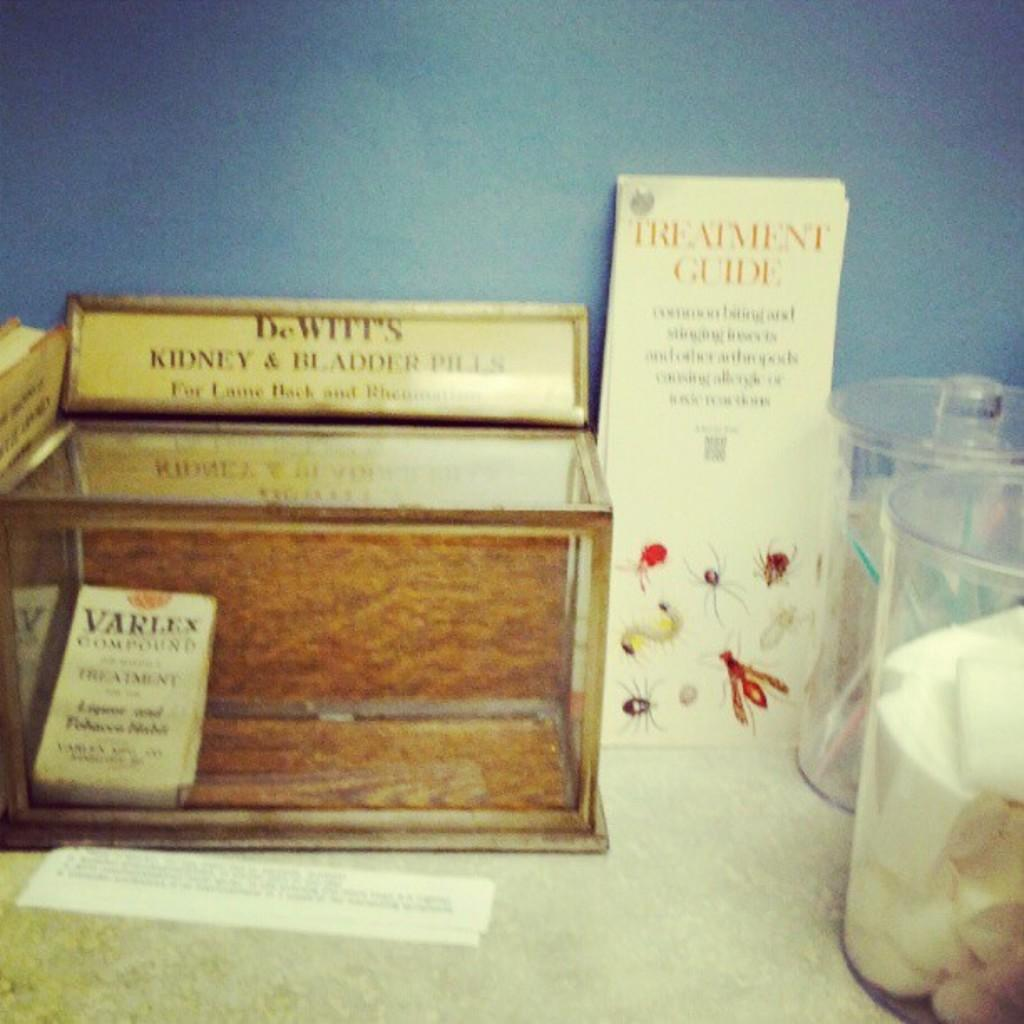What type of wooden object is present in the image? There is a wooden object with text in the image. What else in the image has text on it? There is a card with text in the image. What can be seen in the image that might be used for storage or holding items? There are containers in the image. What type of fuel is being used by the ghost in the image? There is no ghost present in the image, so it is not possible to determine what type of fuel it might be using. 